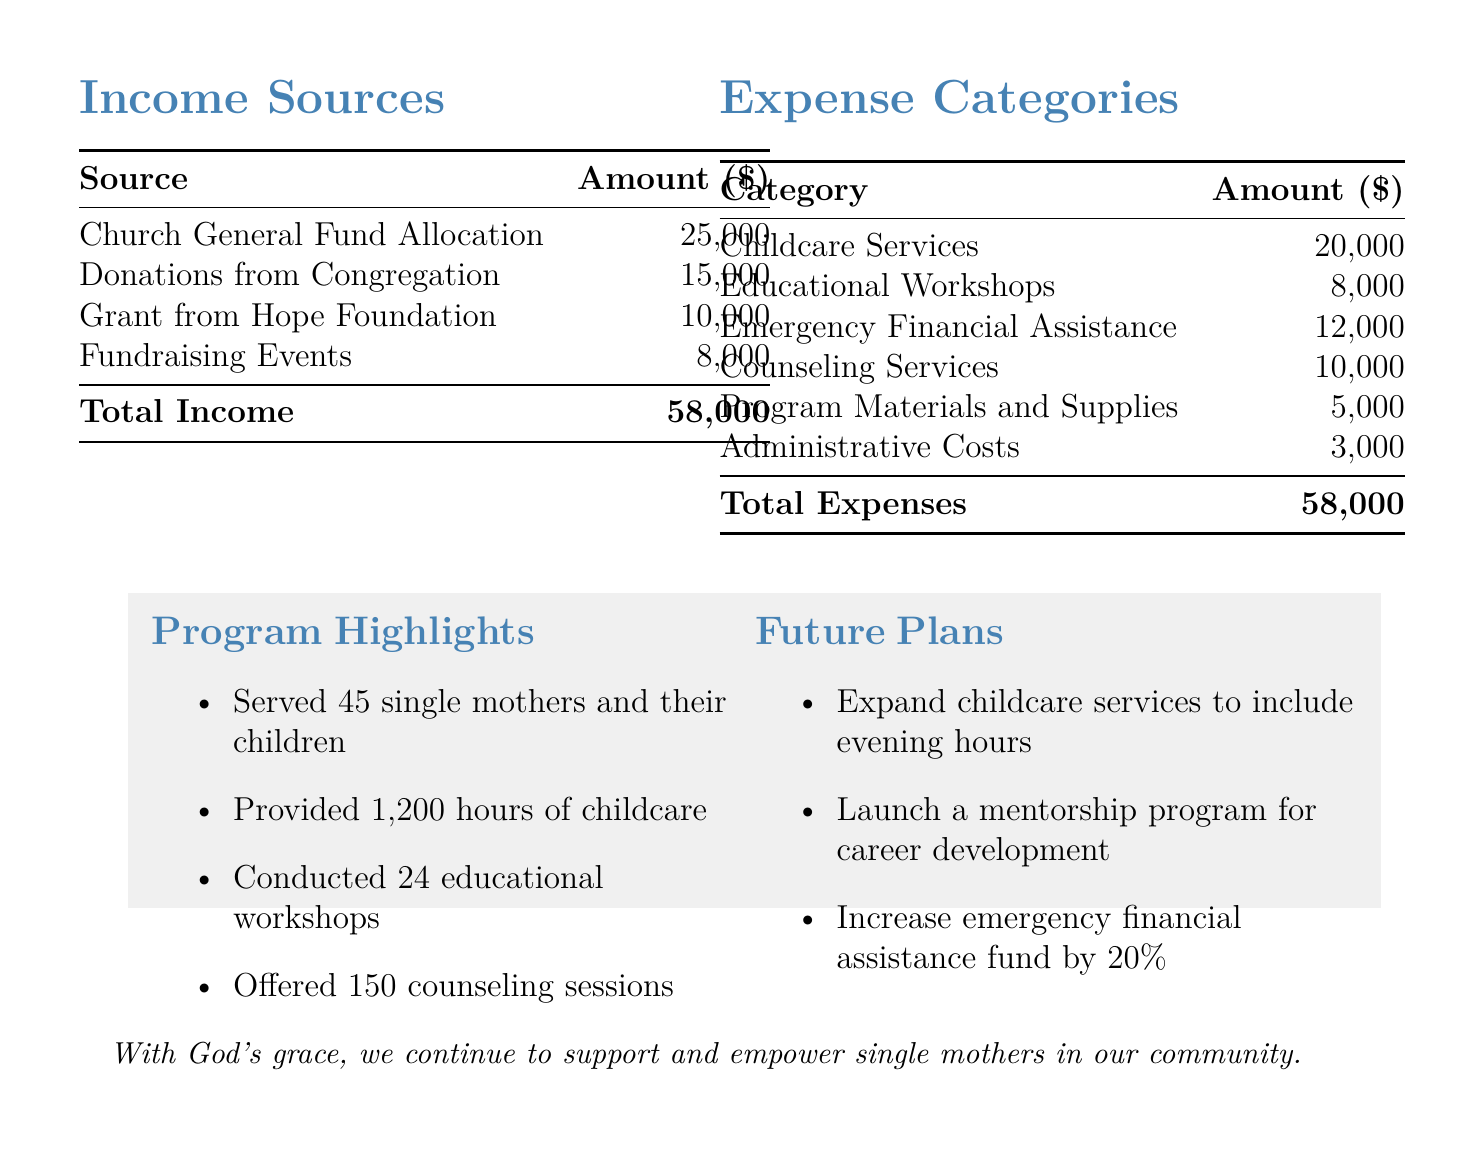What is the total income for the programs? The total income is presented in the income sources section, which sums up to $58000.
Answer: $58000 How much is allocated from the Church General Fund? The amount allocated from the Church General Fund is specified in the income sources, which is $25000.
Answer: $25000 What is the largest expense category? The largest expense category can be identified from the expense categories, which is Childcare Services at $20000.
Answer: Childcare Services How many single mothers were served by the programs? The number of single mothers served is mentioned in the program highlights section, which states 45 single mothers were served.
Answer: 45 What is the planned increase for the emergency financial assistance fund? The future plans state that the emergency financial assistance fund is planned to increase by 20%.
Answer: 20% What was the amount spent on counseling services? The specific amount for counseling services is listed in the expense categories as $10000.
Answer: $10000 How many educational workshops were conducted? The number of educational workshops conducted is mentioned in the program highlights, which states 24 workshops were conducted.
Answer: 24 What is the total amount for administrative costs? The total amount for administrative costs is specified in the expense categories section as $3000.
Answer: $3000 What future program is mentioned for career development? The document specifies plans to launch a mentorship program for career development.
Answer: mentorship program 